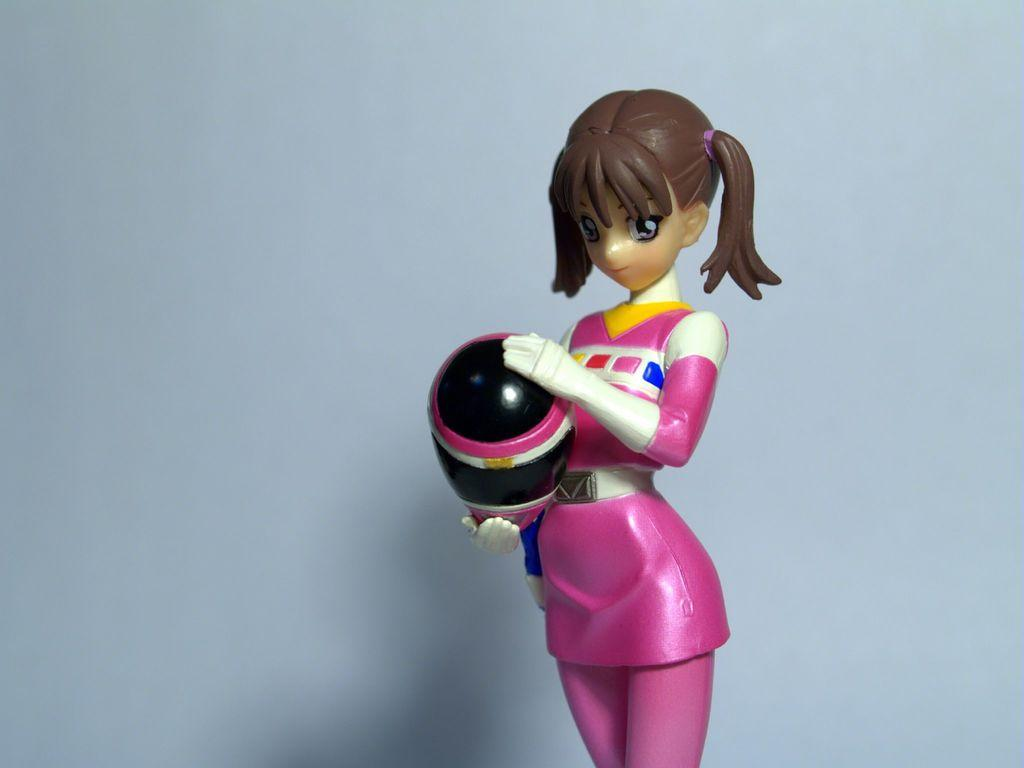What is the main subject in the center of the image? There is a toy girl in the center of the image. What color is the background of the image? The background of the image is white. What type of wine is being served at the meeting in the image? There is no wine or meeting present in the image; it features a toy girl in the center and a white background. Can you describe the bat that is flying in the image? There is no bat present in the image. 